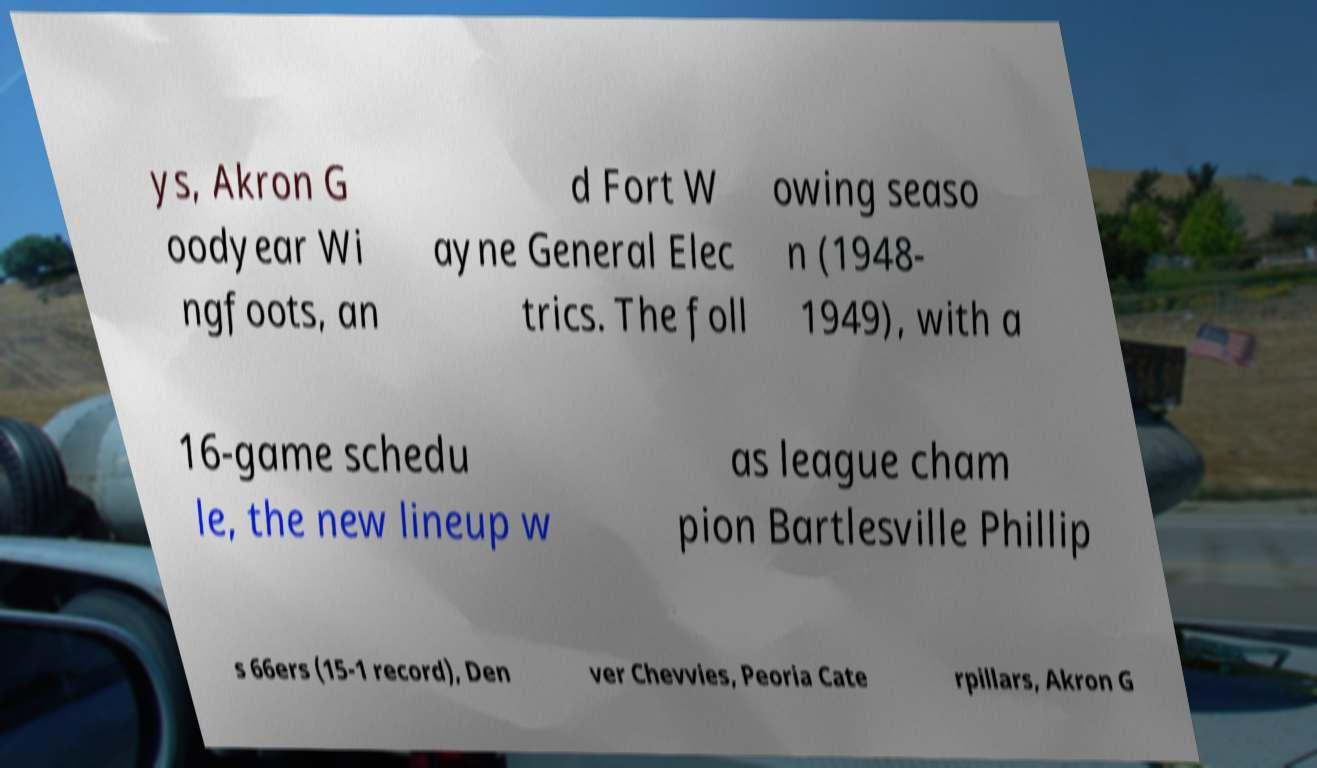Please identify and transcribe the text found in this image. ys, Akron G oodyear Wi ngfoots, an d Fort W ayne General Elec trics. The foll owing seaso n (1948- 1949), with a 16-game schedu le, the new lineup w as league cham pion Bartlesville Phillip s 66ers (15-1 record), Den ver Chevvies, Peoria Cate rpillars, Akron G 